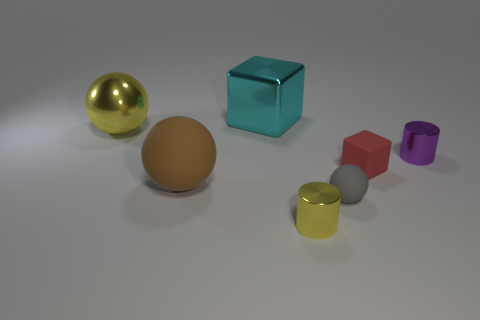There is a yellow metallic object left of the big metal block that is right of the yellow object behind the gray object; what shape is it?
Keep it short and to the point. Sphere. Do the small metallic object that is left of the tiny cube and the large metal object that is on the right side of the brown rubber object have the same shape?
Offer a terse response. No. Are there any large yellow things made of the same material as the cyan object?
Keep it short and to the point. Yes. The cube that is on the left side of the small yellow cylinder that is to the left of the tiny cylinder behind the small red object is what color?
Keep it short and to the point. Cyan. Is the material of the cube that is right of the yellow cylinder the same as the yellow object behind the brown matte object?
Your answer should be compact. No. There is a small matte object in front of the large brown rubber ball; what is its shape?
Offer a terse response. Sphere. How many things are cyan shiny cubes or yellow things that are in front of the small gray rubber sphere?
Your answer should be compact. 2. Is the material of the tiny ball the same as the yellow cylinder?
Your answer should be very brief. No. Are there an equal number of large metallic cubes that are behind the large cyan thing and cyan objects in front of the small gray matte thing?
Your answer should be compact. Yes. There is a small purple cylinder; how many purple cylinders are to the left of it?
Your response must be concise. 0. 